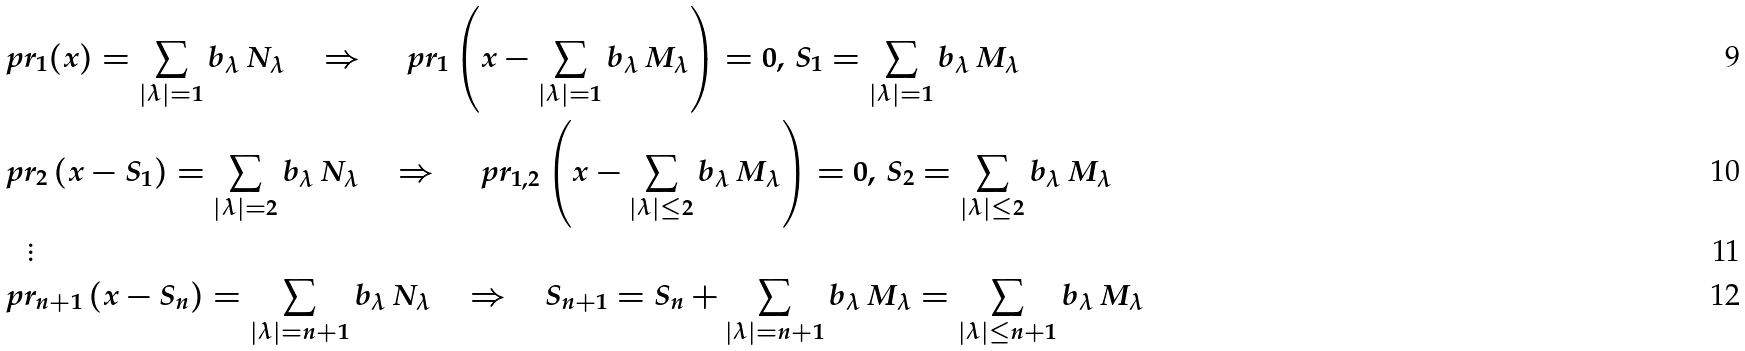<formula> <loc_0><loc_0><loc_500><loc_500>& \ p r _ { 1 } ( x ) = \sum _ { | \lambda | = 1 } b _ { \lambda } \, N _ { \lambda } \quad \Rightarrow \quad \ p r _ { 1 } \left ( x - \sum _ { | \lambda | = 1 } b _ { \lambda } \, M _ { \lambda } \right ) = 0 , \, S _ { 1 } = \sum _ { | \lambda | = 1 } b _ { \lambda } \, M _ { \lambda } \\ & \ p r _ { 2 } \left ( x - S _ { 1 } \right ) = \sum _ { | \lambda | = 2 } b _ { \lambda } \, N _ { \lambda } \quad \Rightarrow \quad \ p r _ { 1 , 2 } \left ( x - \sum _ { | \lambda | \leq 2 } b _ { \lambda } \, M _ { \lambda } \right ) = 0 , \, S _ { 2 } = \sum _ { | \lambda | \leq 2 } b _ { \lambda } \, M _ { \lambda } \\ & \quad \vdots \\ & \ p r _ { n + 1 } \left ( x - S _ { n } \right ) = \sum _ { | \lambda | = n + 1 } b _ { \lambda } \, N _ { \lambda } \quad \Rightarrow \quad S _ { n + 1 } = S _ { n } + \sum _ { | \lambda | = n + 1 } b _ { \lambda } \, M _ { \lambda } = \sum _ { | \lambda | \leq n + 1 } b _ { \lambda } \, M _ { \lambda }</formula> 